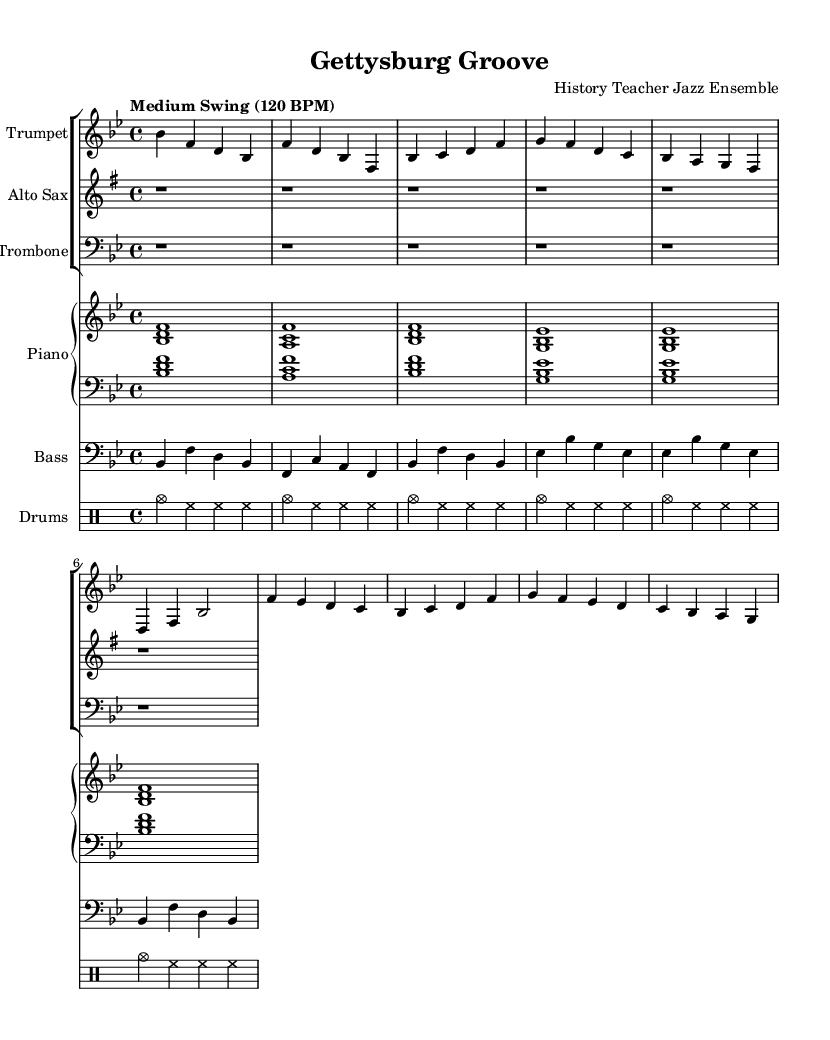What is the key signature of this music? The key signature indicated in the sheet music is B flat major, which has two flats (B flat and E flat). This is identified at the beginning of the score by the key signature symbol present after the clef.
Answer: B flat major What is the time signature of this music? The time signature found at the beginning of the score is 4/4, which denotes that there are four beats in a measure and the quarter note gets one beat. This is indicated right after the key signature notation.
Answer: 4/4 What is the tempo marking for this piece? The tempo marking indicates "Medium Swing (120 BPM)" at the beginning of the score. This informs the musician of the speed of the piece and the swing feel that is characteristic of jazz.
Answer: Medium Swing (120 BPM) How many measures are present in the A section of the composition? The A section consists of eight measures as indicated by the structure of the score. By counting the measures delineated by bar lines, we conclude that there are eight measures defined in that section.
Answer: 8 measures Which instrument has an intro in the score? The Trumpet instrument has an intro indicated in the score, with specific notes played before the A section begins. In this score, it is common for one lead instrument to perform the intro, which is present here.
Answer: Trumpet What type of jazz ensemble is indicated for this piece? The title indicates that it is composed for a "Jazz Ensemble." This context gives a clue that we can expect a combination of brass, rhythm, and possibly woodwind instruments playing together, which is standard in jazz compositions.
Answer: Jazz Ensemble What is the primary compositional theme inspired by this music piece? The title "Gettysburg Groove" suggests that this composition draws inspiration from the Battle of Gettysburg during the Civil War. The title directly reflects a historical theme, thereby connecting the musical narrative to a significant event in military history.
Answer: Battle of Gettysburg 